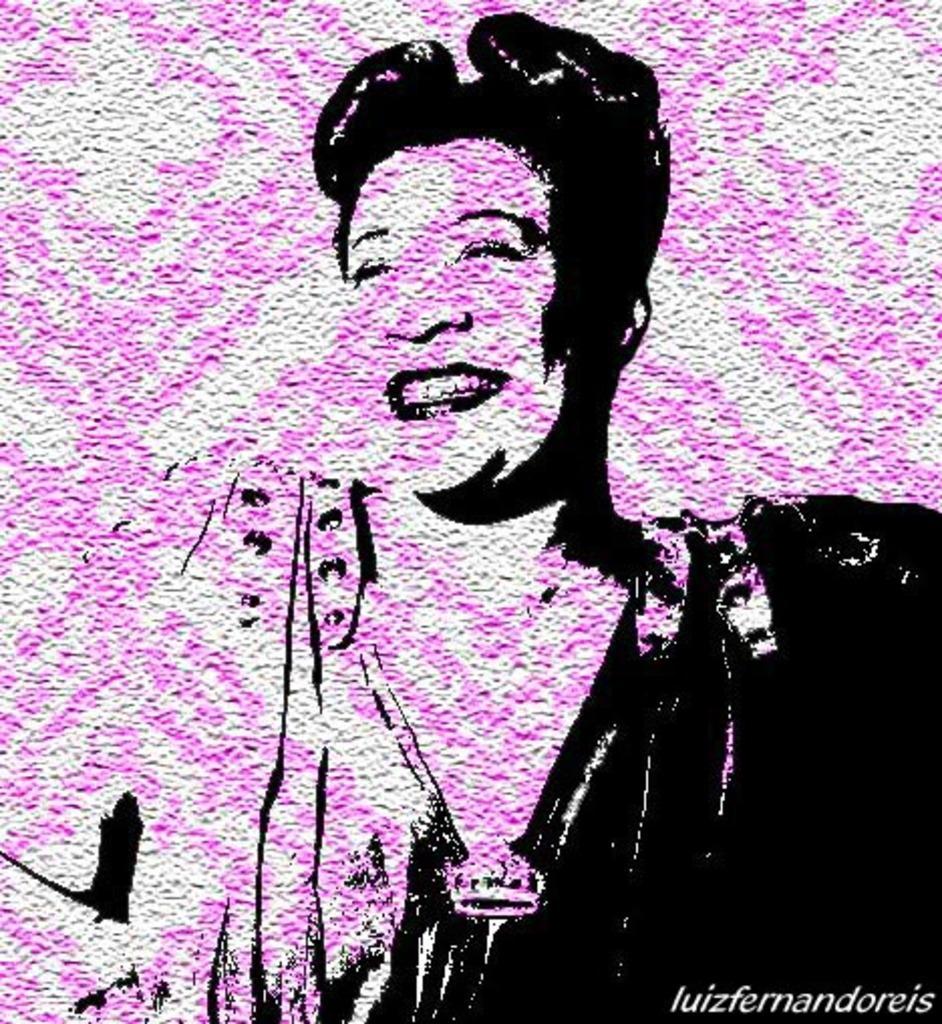Could you give a brief overview of what you see in this image? In this image, we can see a sketch of a person on the wall and there is some text. 